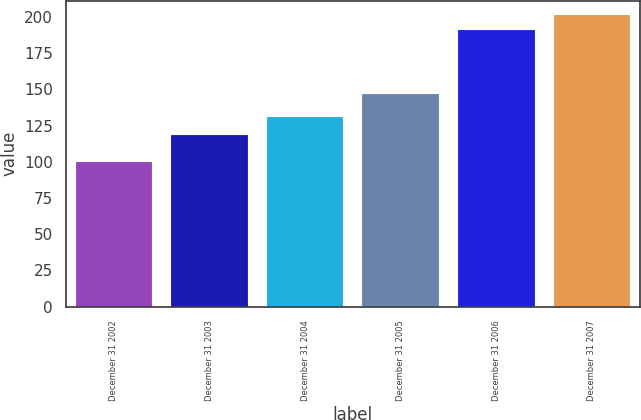Convert chart to OTSL. <chart><loc_0><loc_0><loc_500><loc_500><bar_chart><fcel>December 31 2002<fcel>December 31 2003<fcel>December 31 2004<fcel>December 31 2005<fcel>December 31 2006<fcel>December 31 2007<nl><fcel>100<fcel>118.8<fcel>130.66<fcel>146.97<fcel>191.27<fcel>201.08<nl></chart> 